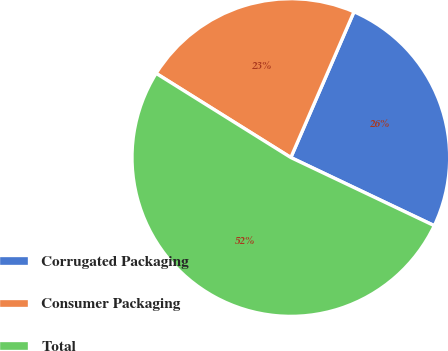<chart> <loc_0><loc_0><loc_500><loc_500><pie_chart><fcel>Corrugated Packaging<fcel>Consumer Packaging<fcel>Total<nl><fcel>25.55%<fcel>22.62%<fcel>51.83%<nl></chart> 